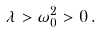<formula> <loc_0><loc_0><loc_500><loc_500>\lambda > \omega _ { 0 } ^ { 2 } > 0 \, .</formula> 